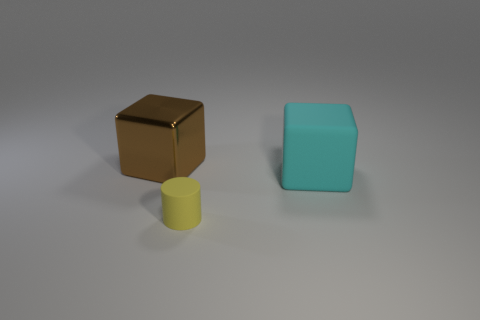Subtract all cylinders. How many objects are left? 2 Add 2 small metal objects. How many objects exist? 5 Subtract all matte cylinders. Subtract all yellow cylinders. How many objects are left? 1 Add 1 brown cubes. How many brown cubes are left? 2 Add 3 big yellow blocks. How many big yellow blocks exist? 3 Subtract 0 gray spheres. How many objects are left? 3 